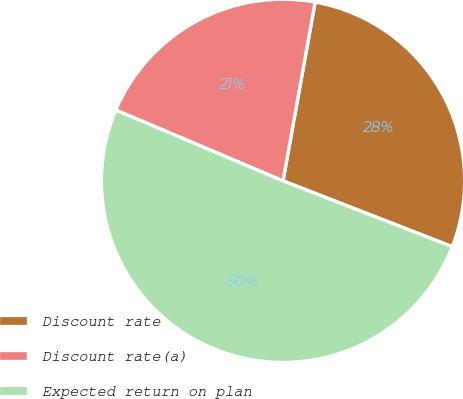<chart> <loc_0><loc_0><loc_500><loc_500><pie_chart><fcel>Discount rate<fcel>Discount rate(a)<fcel>Expected return on plan<nl><fcel>28.08%<fcel>21.45%<fcel>50.47%<nl></chart> 